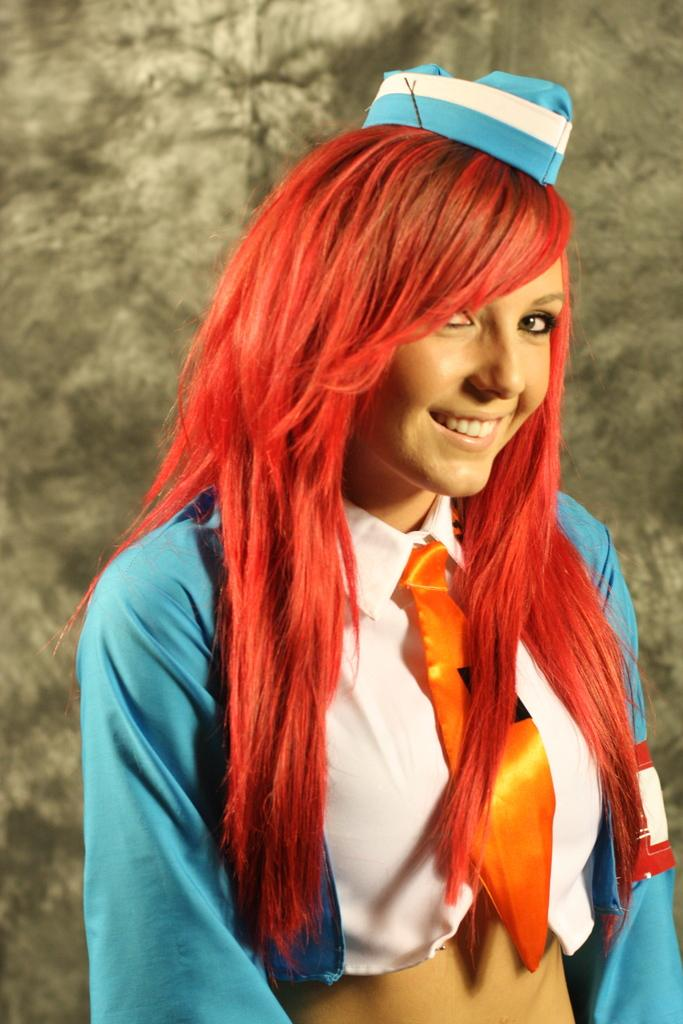What is the main subject of the image? There is a woman standing in the image. What is the woman wearing on her head? The woman is wearing a blue cap. What is the woman wearing on her upper body? The woman is wearing a blue coat and a white shirt. What is the woman wearing around her neck? The woman is wearing an orange tie. What can be seen in the background of the image? There is a brown surface in the background of the image. What month is depicted in the image? There is no month depicted in the image; it is a still photograph of a woman. How many copies of the woman are present in the image? There is only one woman present in the image. 